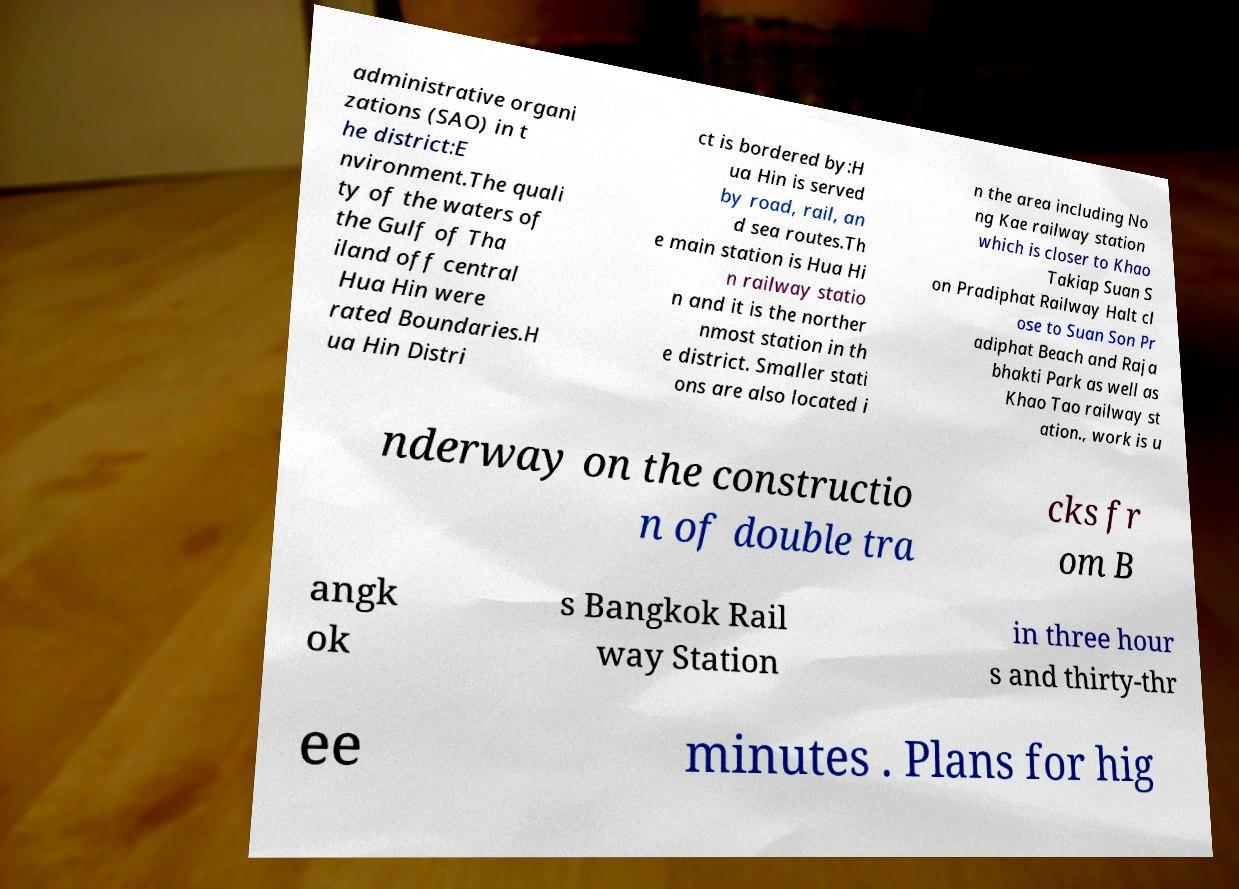Please identify and transcribe the text found in this image. administrative organi zations (SAO) in t he district:E nvironment.The quali ty of the waters of the Gulf of Tha iland off central Hua Hin were rated Boundaries.H ua Hin Distri ct is bordered by:H ua Hin is served by road, rail, an d sea routes.Th e main station is Hua Hi n railway statio n and it is the norther nmost station in th e district. Smaller stati ons are also located i n the area including No ng Kae railway station which is closer to Khao Takiap Suan S on Pradiphat Railway Halt cl ose to Suan Son Pr adiphat Beach and Raja bhakti Park as well as Khao Tao railway st ation., work is u nderway on the constructio n of double tra cks fr om B angk ok s Bangkok Rail way Station in three hour s and thirty-thr ee minutes . Plans for hig 